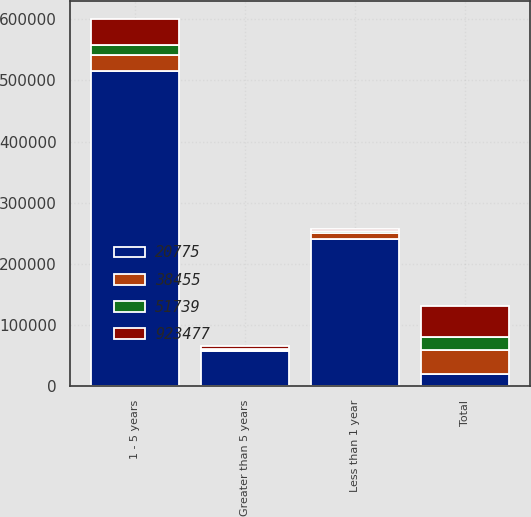Convert chart to OTSL. <chart><loc_0><loc_0><loc_500><loc_500><stacked_bar_chart><ecel><fcel>Less than 1 year<fcel>1 - 5 years<fcel>Greater than 5 years<fcel>Total<nl><fcel>20775<fcel>240468<fcel>514986<fcel>57054<fcel>20775<nl><fcel>923477<fcel>2859<fcel>42399<fcel>6481<fcel>51739<nl><fcel>51739<fcel>2881<fcel>16327<fcel>1567<fcel>20775<nl><fcel>38455<fcel>10533<fcel>26271<fcel>1651<fcel>38455<nl></chart> 